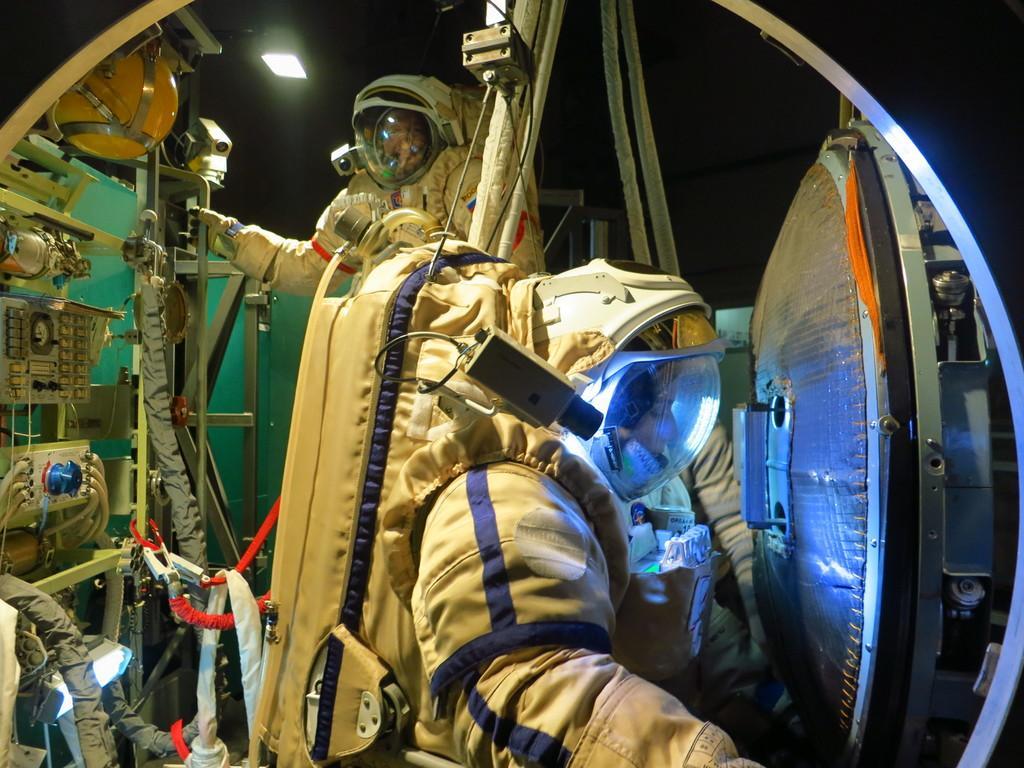Could you give a brief overview of what you see in this image? In this image I can see two persons wearing astronaut dresses which are cream and blue in color. I can see few other equipment, a light and the dark background. 